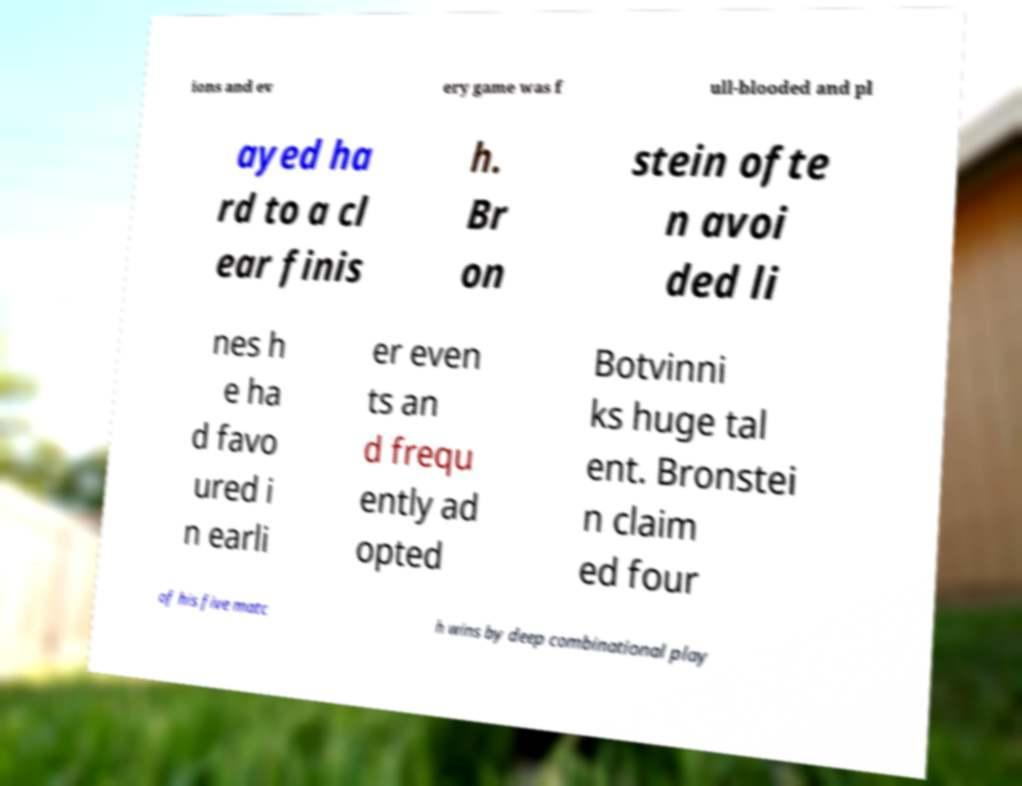Could you extract and type out the text from this image? ions and ev ery game was f ull-blooded and pl ayed ha rd to a cl ear finis h. Br on stein ofte n avoi ded li nes h e ha d favo ured i n earli er even ts an d frequ ently ad opted Botvinni ks huge tal ent. Bronstei n claim ed four of his five matc h wins by deep combinational play 